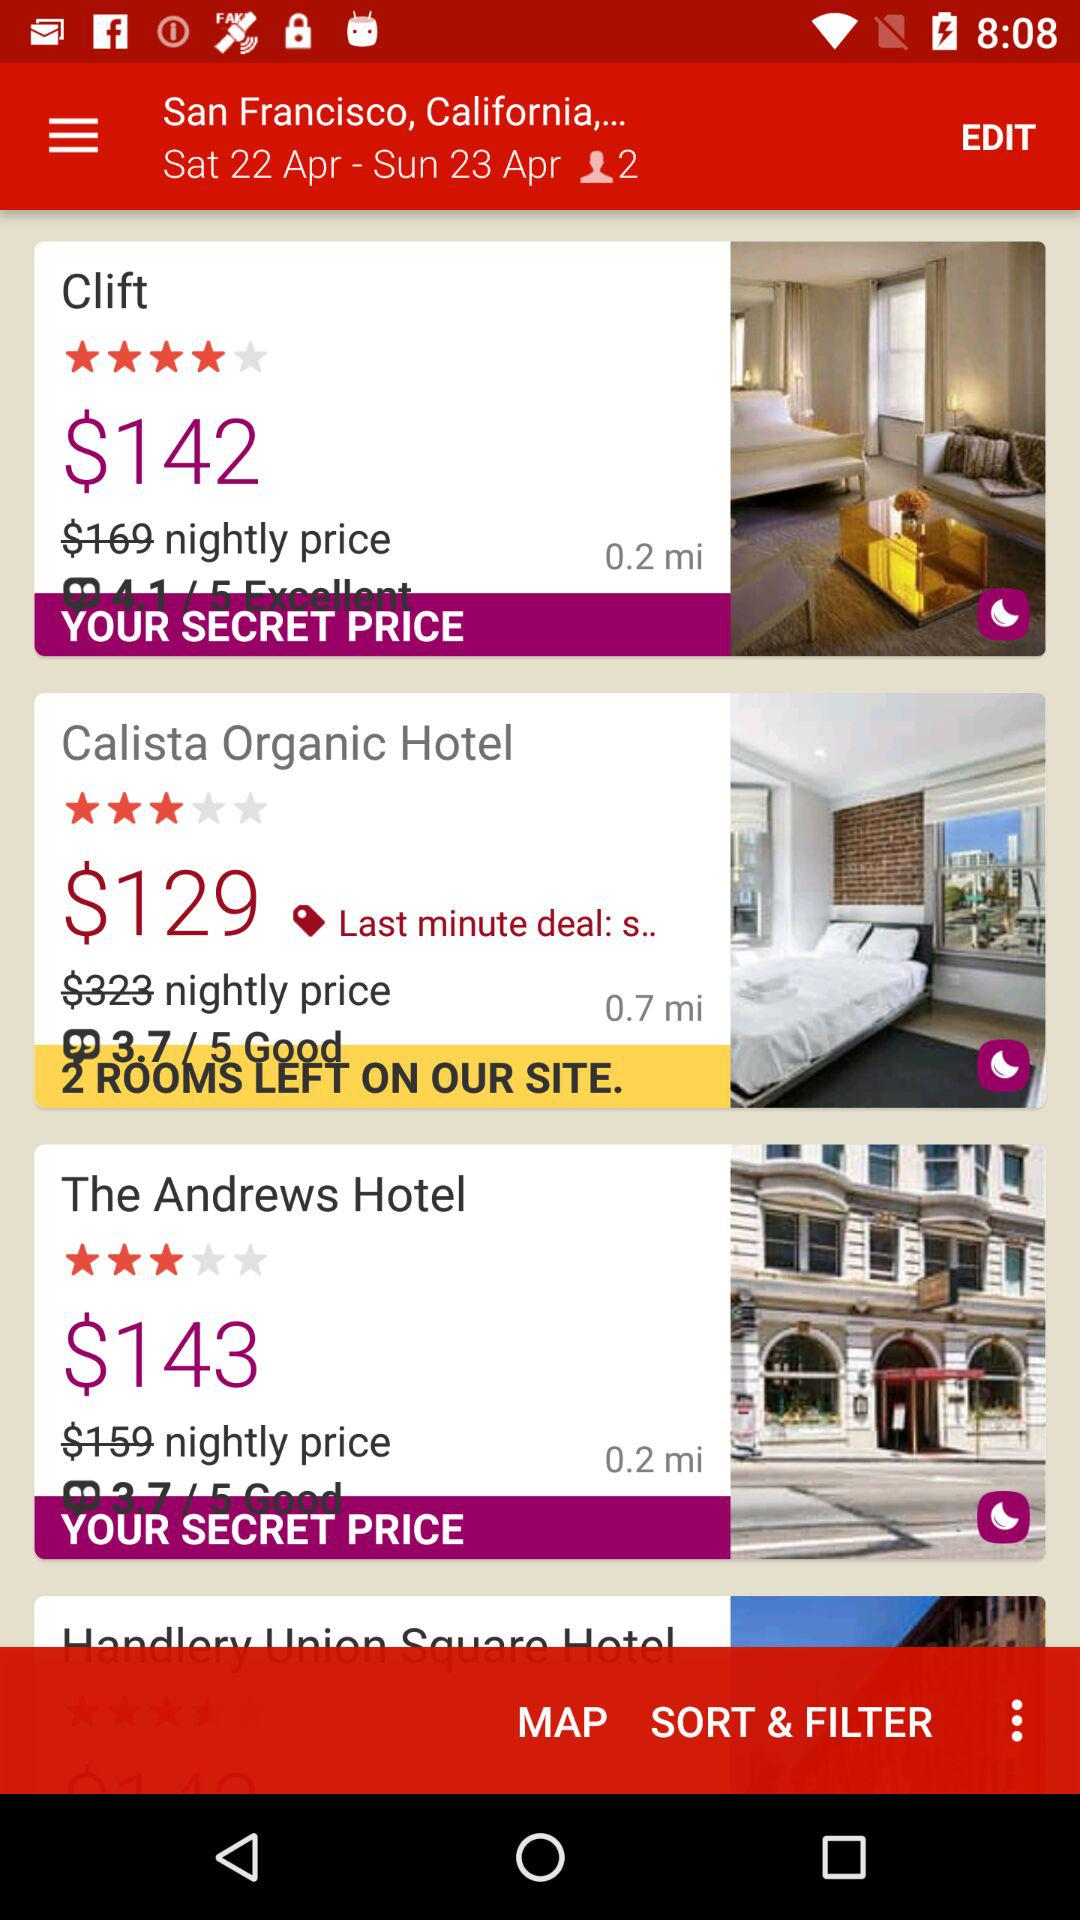What is the reservation cost after discount for "The Andrews Hotel"? The reservation cost after discount for "The Andrews Hotel" is $143. 